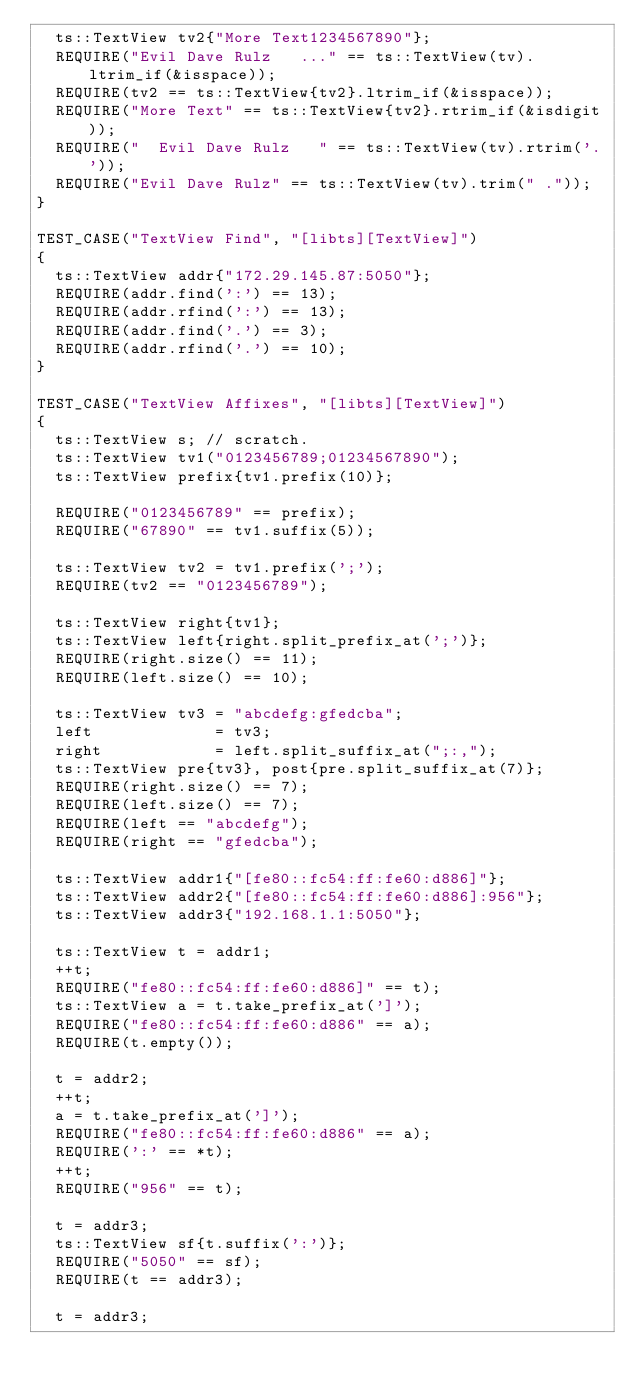Convert code to text. <code><loc_0><loc_0><loc_500><loc_500><_C++_>  ts::TextView tv2{"More Text1234567890"};
  REQUIRE("Evil Dave Rulz   ..." == ts::TextView(tv).ltrim_if(&isspace));
  REQUIRE(tv2 == ts::TextView{tv2}.ltrim_if(&isspace));
  REQUIRE("More Text" == ts::TextView{tv2}.rtrim_if(&isdigit));
  REQUIRE("  Evil Dave Rulz   " == ts::TextView(tv).rtrim('.'));
  REQUIRE("Evil Dave Rulz" == ts::TextView(tv).trim(" ."));
}

TEST_CASE("TextView Find", "[libts][TextView]")
{
  ts::TextView addr{"172.29.145.87:5050"};
  REQUIRE(addr.find(':') == 13);
  REQUIRE(addr.rfind(':') == 13);
  REQUIRE(addr.find('.') == 3);
  REQUIRE(addr.rfind('.') == 10);
}

TEST_CASE("TextView Affixes", "[libts][TextView]")
{
  ts::TextView s; // scratch.
  ts::TextView tv1("0123456789;01234567890");
  ts::TextView prefix{tv1.prefix(10)};

  REQUIRE("0123456789" == prefix);
  REQUIRE("67890" == tv1.suffix(5));

  ts::TextView tv2 = tv1.prefix(';');
  REQUIRE(tv2 == "0123456789");

  ts::TextView right{tv1};
  ts::TextView left{right.split_prefix_at(';')};
  REQUIRE(right.size() == 11);
  REQUIRE(left.size() == 10);

  ts::TextView tv3 = "abcdefg:gfedcba";
  left             = tv3;
  right            = left.split_suffix_at(";:,");
  ts::TextView pre{tv3}, post{pre.split_suffix_at(7)};
  REQUIRE(right.size() == 7);
  REQUIRE(left.size() == 7);
  REQUIRE(left == "abcdefg");
  REQUIRE(right == "gfedcba");

  ts::TextView addr1{"[fe80::fc54:ff:fe60:d886]"};
  ts::TextView addr2{"[fe80::fc54:ff:fe60:d886]:956"};
  ts::TextView addr3{"192.168.1.1:5050"};

  ts::TextView t = addr1;
  ++t;
  REQUIRE("fe80::fc54:ff:fe60:d886]" == t);
  ts::TextView a = t.take_prefix_at(']');
  REQUIRE("fe80::fc54:ff:fe60:d886" == a);
  REQUIRE(t.empty());

  t = addr2;
  ++t;
  a = t.take_prefix_at(']');
  REQUIRE("fe80::fc54:ff:fe60:d886" == a);
  REQUIRE(':' == *t);
  ++t;
  REQUIRE("956" == t);

  t = addr3;
  ts::TextView sf{t.suffix(':')};
  REQUIRE("5050" == sf);
  REQUIRE(t == addr3);

  t = addr3;</code> 